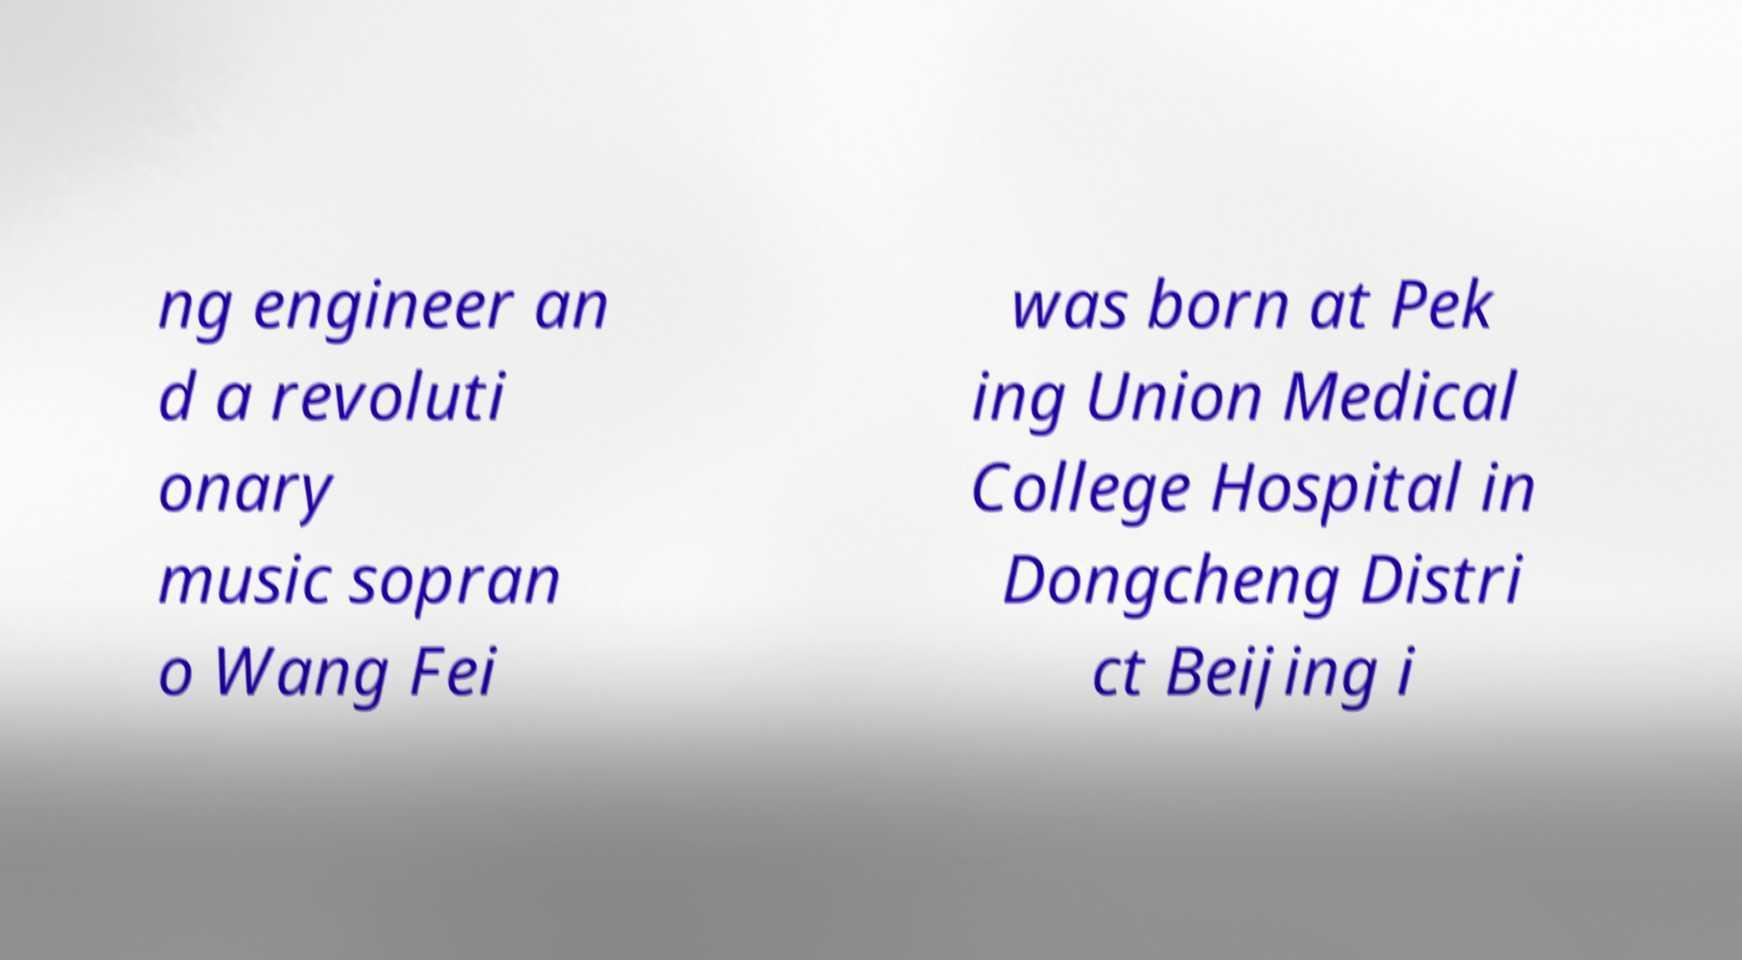Please identify and transcribe the text found in this image. ng engineer an d a revoluti onary music sopran o Wang Fei was born at Pek ing Union Medical College Hospital in Dongcheng Distri ct Beijing i 